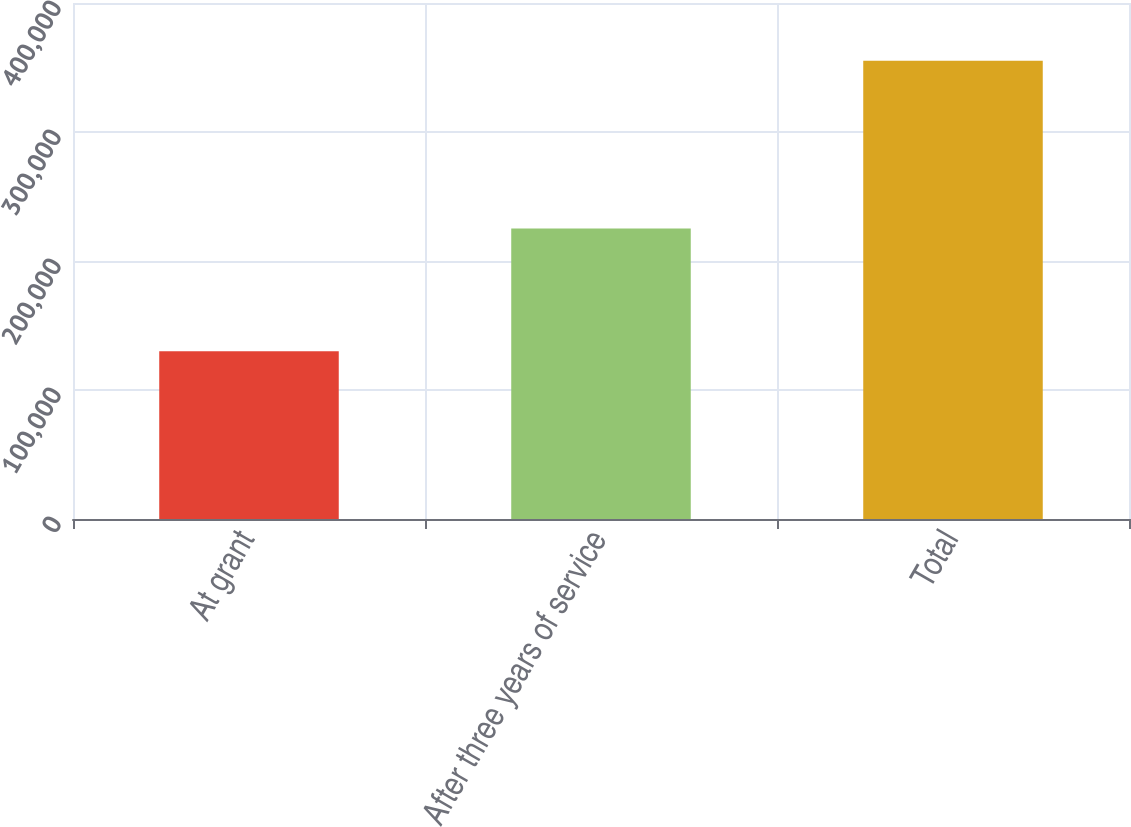Convert chart to OTSL. <chart><loc_0><loc_0><loc_500><loc_500><bar_chart><fcel>At grant<fcel>After three years of service<fcel>Total<nl><fcel>130123<fcel>225186<fcel>355309<nl></chart> 